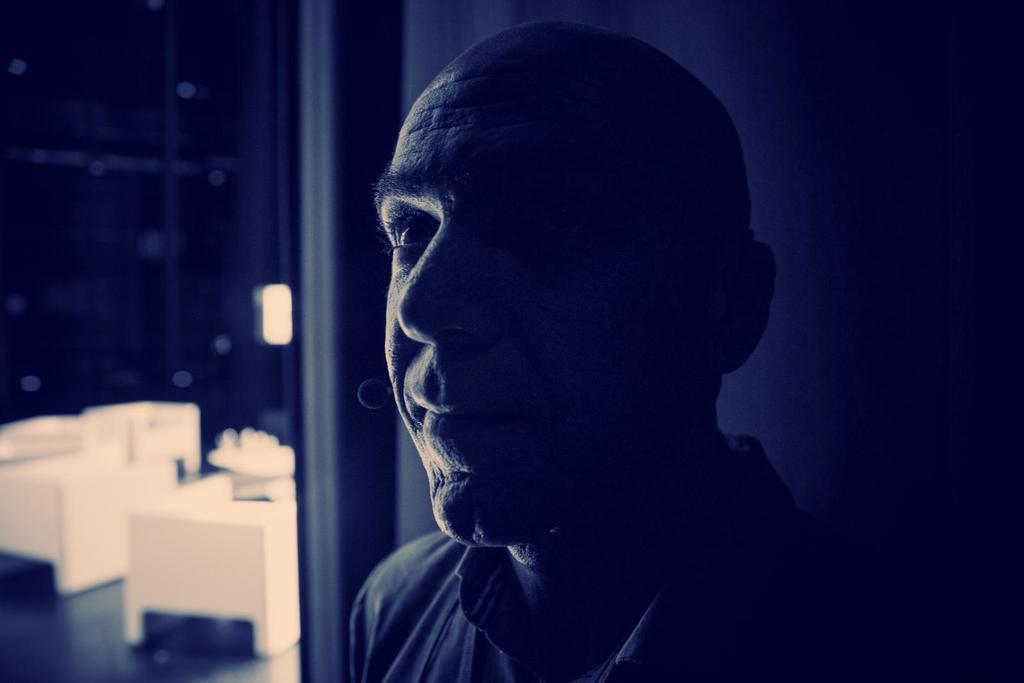Who is present in the image? There is a man in the image. What can be seen on the left side of the image? There are chairs on the left side of the image. What is the color of the chairs? The chairs are white in color. What type of wall is visible in the image? There is a glass wall in the image. What type of lipstick is the man wearing in the image? The man in the image is a doll, and dolls do not wear lipstick. 